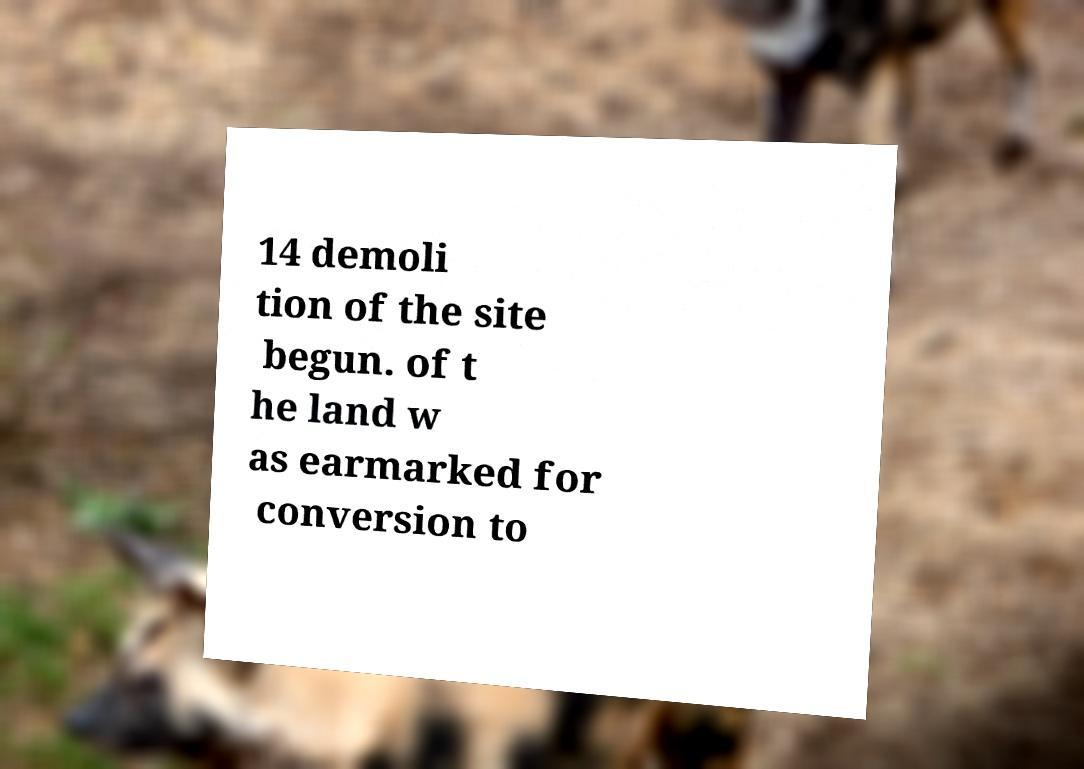Please identify and transcribe the text found in this image. 14 demoli tion of the site begun. of t he land w as earmarked for conversion to 